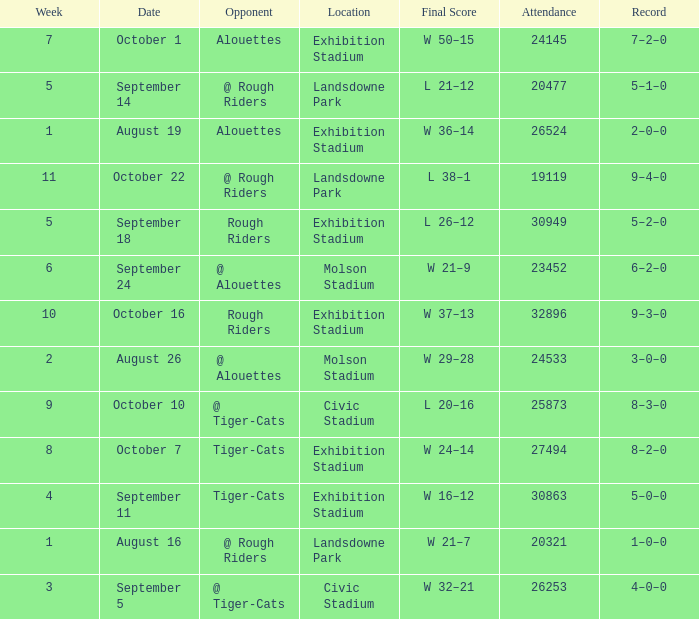How many values for attendance on the date of September 5? 1.0. 